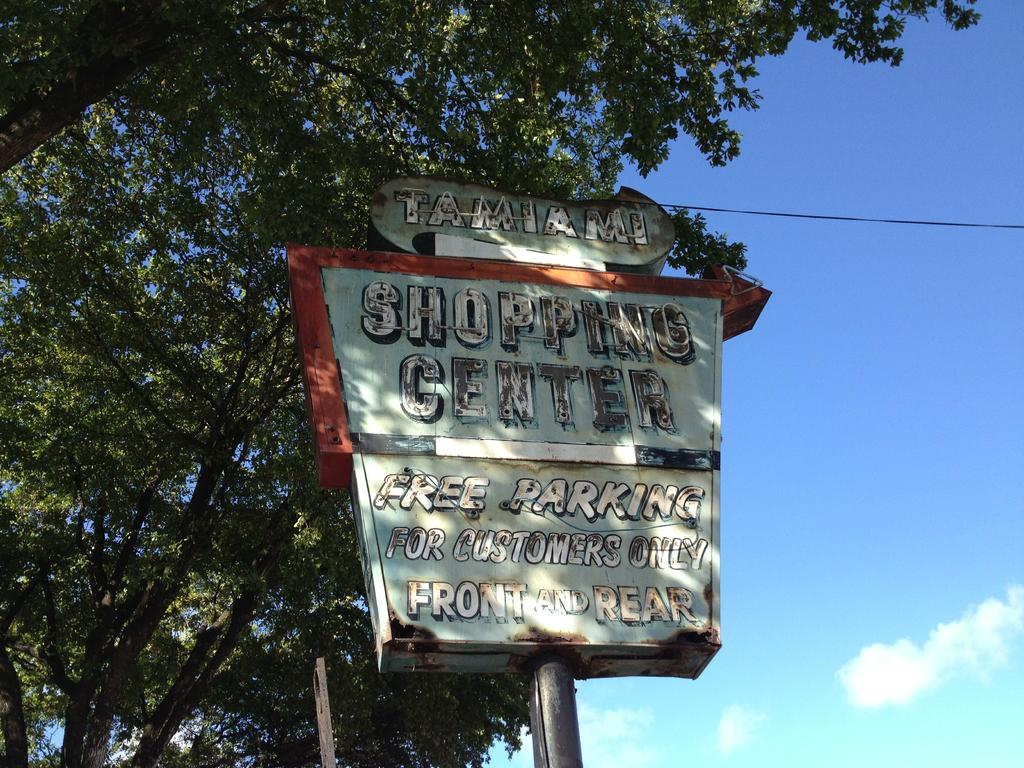What is the main object in the image? There is a sign board in the image. What is written or displayed on the sign board? There is text on the sign board. What can be seen in the background of the image? There are trees and the sky visible in the background of the image. What type of coil is used in the image? There is no coil present in the image. 